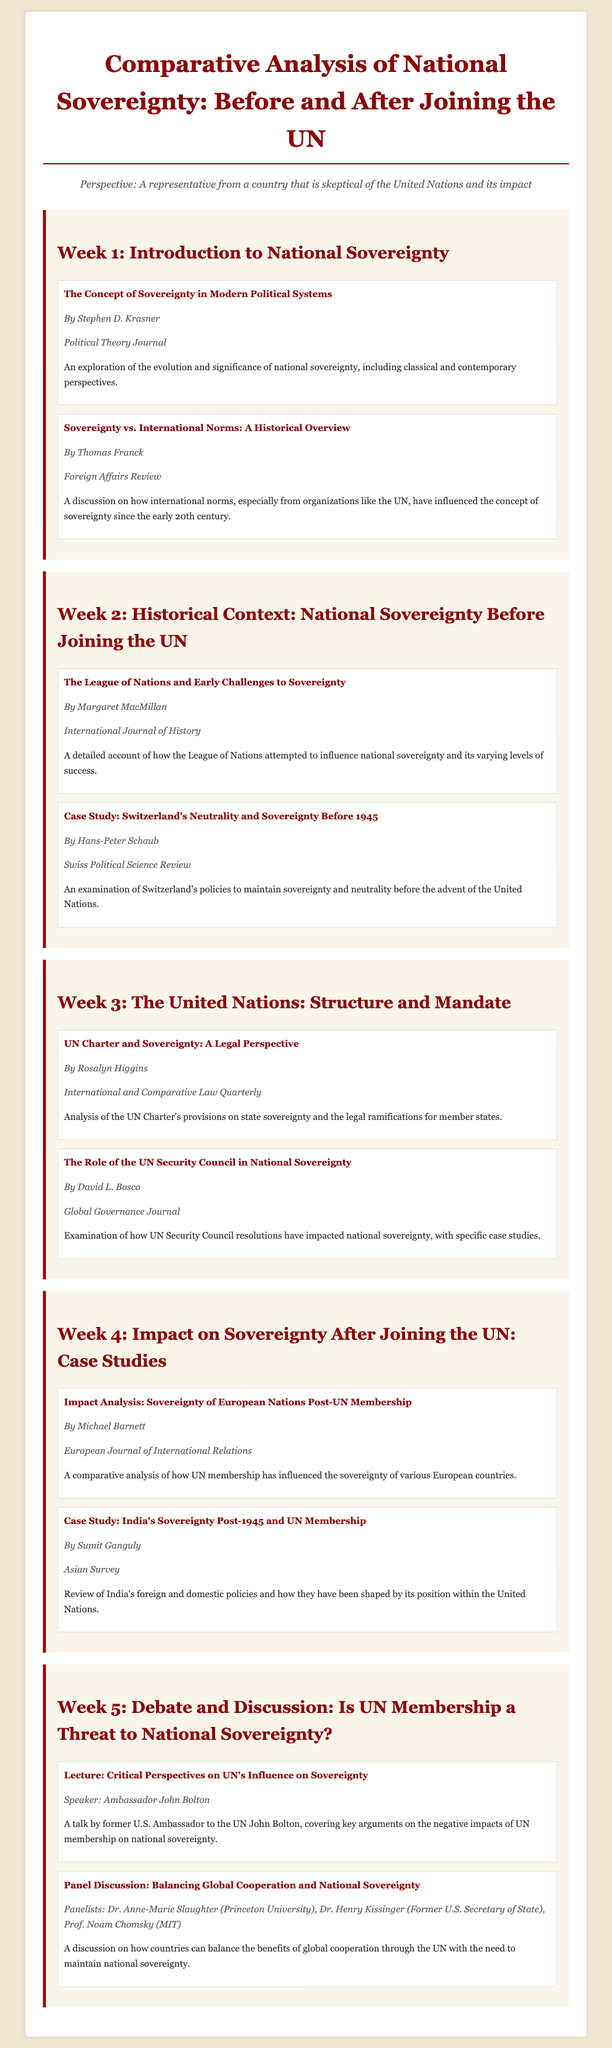What is the title of the syllabus? The title of the syllabus is explicitly mentioned at the top of the document.
Answer: Comparative Analysis of National Sovereignty: Before and After Joining the UN Who authored the reading "The Concept of Sovereignty in Modern Political Systems"? The author of this reading is provided in the respective section of the document.
Answer: Stephen D. Krasner What week focuses on the historical context of national sovereignty? This information can be found under the week headings in the document.
Answer: Week 2 Which country is the focus of a case study in Week 4? The case study mentioned in Week 4 specifically identifies the country in question.
Answer: India Who is the speaker for the lecture in Week 5? The name of the speaker is listed in the activity section of Week 5.
Answer: Ambassador John Bolton What is discussed in the panel in Week 5? The summary of the panel discussion gives insight into its main theme.
Answer: Balancing Global Cooperation and National Sovereignty How many readings are assigned in Week 1? The document outlines the number of readings present in that week.
Answer: 2 What journal is "Sovereignty vs. International Norms: A Historical Overview" published in? The source details indicate the specific journal for this reading.
Answer: Foreign Affairs Review 